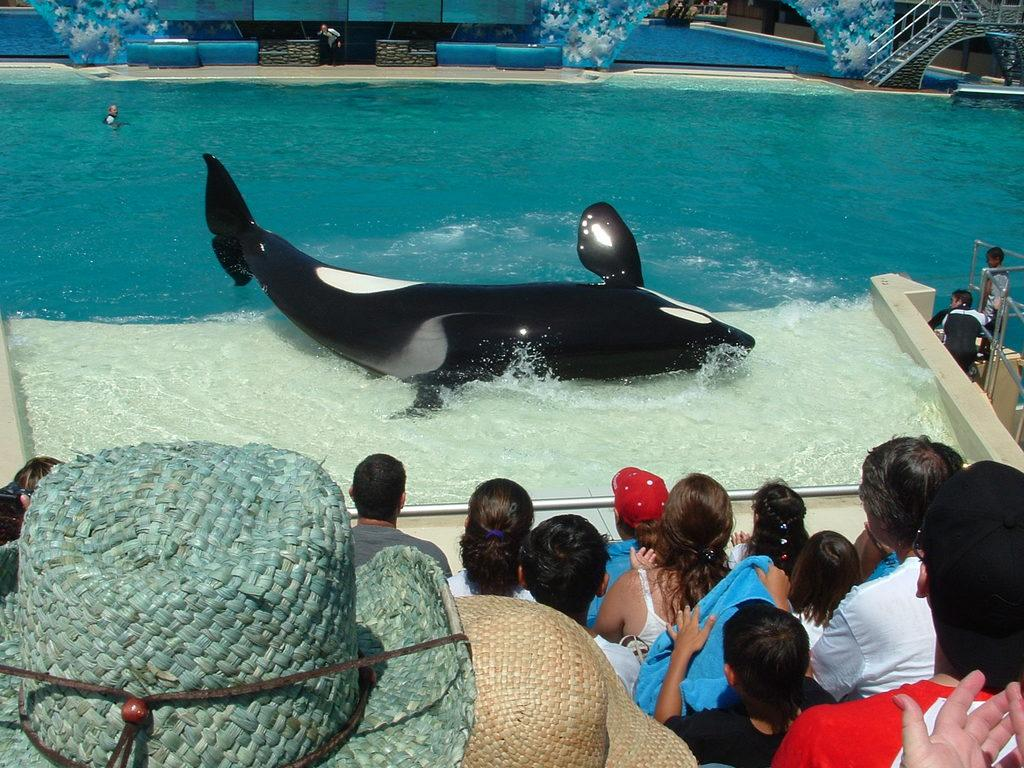Who or what can be seen in the image? There are people and an aquatic animal in the image. What is the color scheme of the image? The image is in black and white. What is the aquatic animal situated in? There is water visible in the image, and the aquatic animal is likely in that water. What structures are present in the image? There are poles and stairs in the image. What color are the objects in the image? There are objects in blue and white color in the image. How many tickets can be seen in the image? There are no tickets present in the image. What type of donkey is visible in the image? There is no donkey present in the image. 